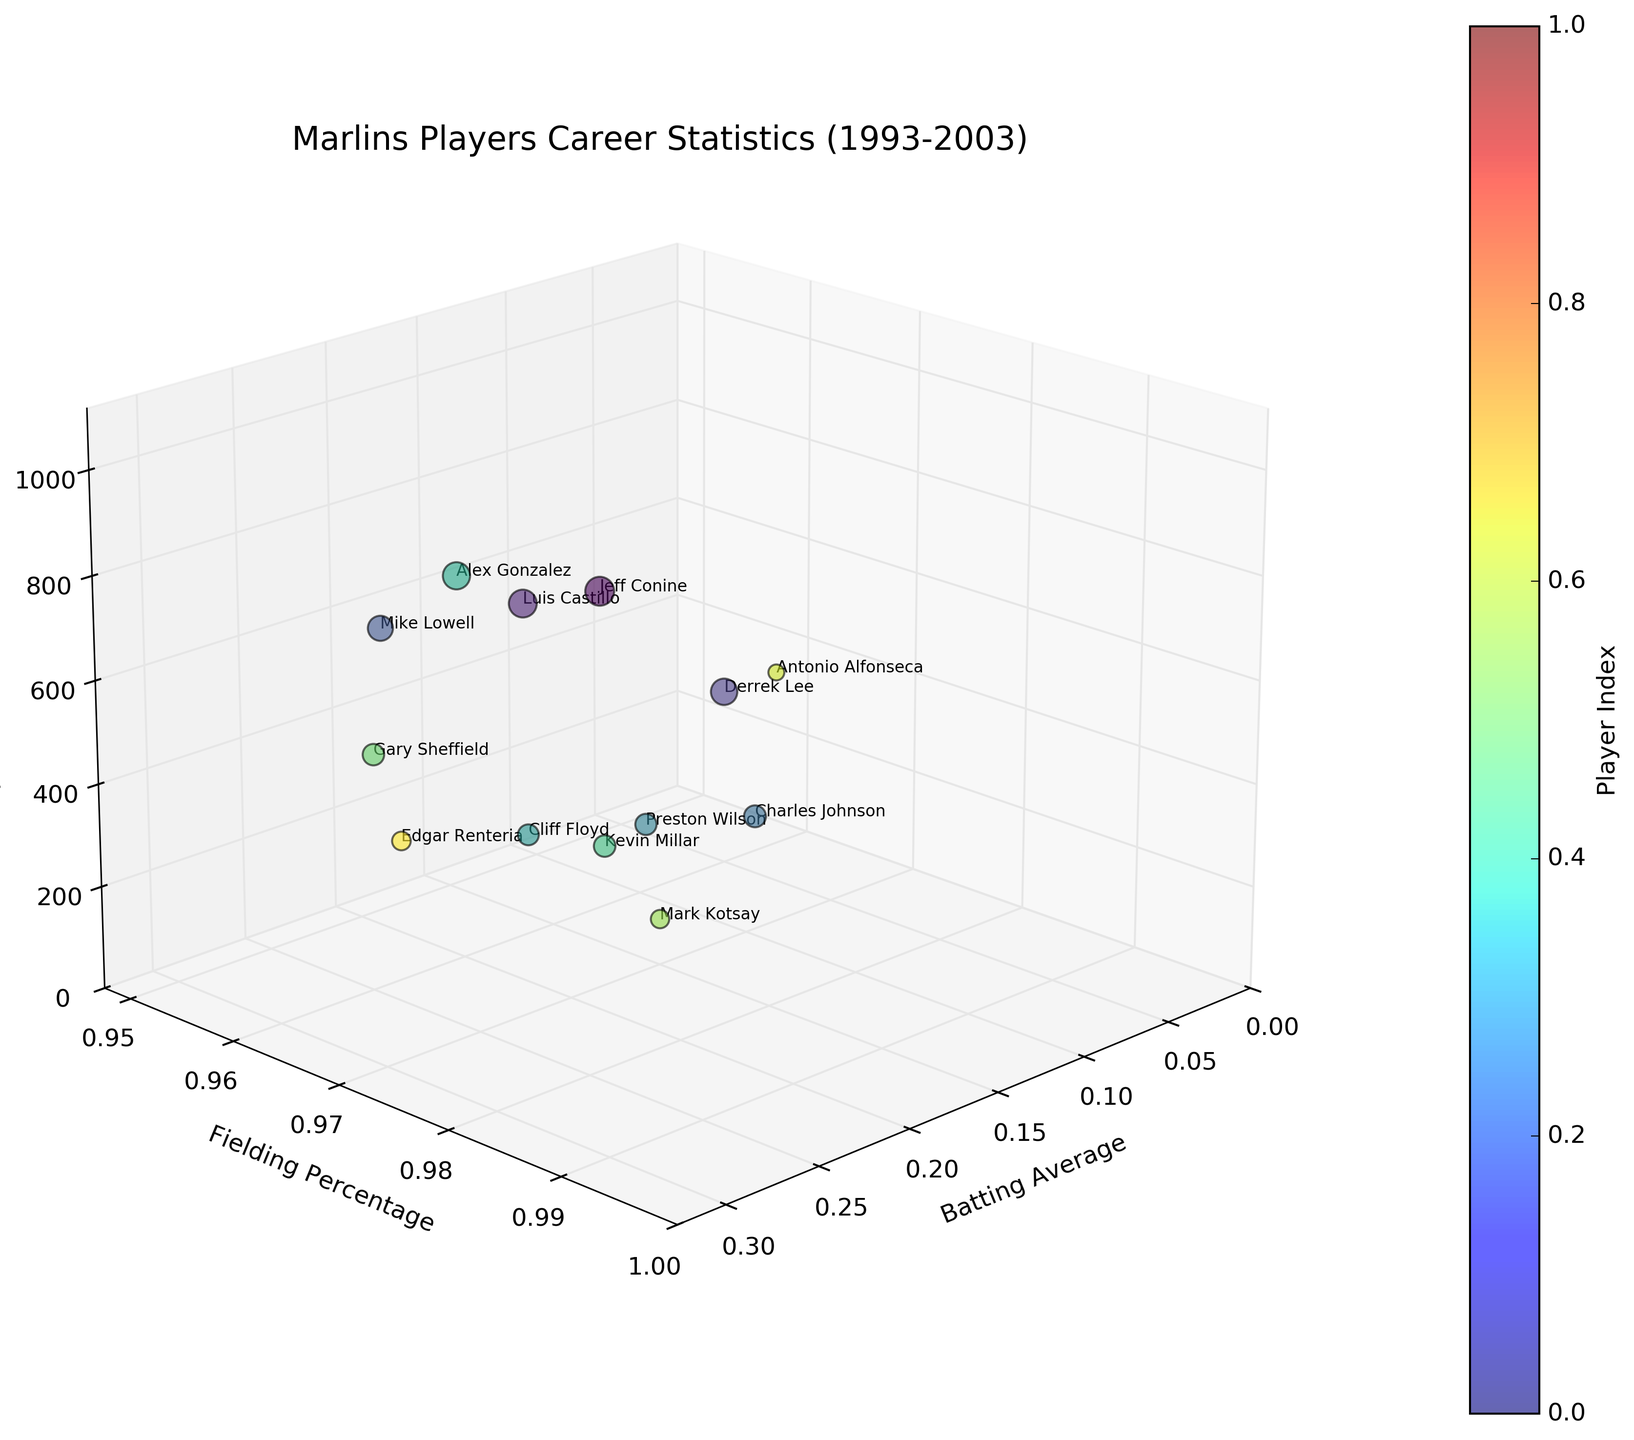What is the title of the chart? The title of the chart is usually written at the top of the figure. Here it is 'Marlins Players Career Statistics (1993-2003)'.
Answer: Marlins Players Career Statistics (1993-2003) Which player has the highest fielding percentage? By looking at the highest point on the y-axis (Fielding Percentage), the player with the highest fielding percentage is Derrek Lee with 0.994.
Answer: Derrek Lee Among Conine, Castillo, and Lee, who played the most games? By observing the z-axis (Games Played), Jeff Conine clearly has the highest value of 1014 games compared to Castillo's 941 and Lee's 844.
Answer: Jeff Conine What is the range of Batting Averages displayed on the x-axis? The x-axis (Batting Average) ranges from 0 to approximately the highest batting average shown. With the highest to be 0.296, the range is from 0 to 0.296.
Answer: 0 to 0.296 Which player has the highest Batting Average and how many games did they play? By looking at the highest point on the x-axis (Batting Average), Kevin Millar has the highest value of 0.296. He played 565 games, as indicated by his bubble size and position on the z-axis.
Answer: Kevin Millar, 565 Which player has the lowest fielding percentage and what is their Batting Average? The lowest fielding percentage on the y-axis is 0.957, belonging to Antonio Alfonseca, and his Batting Average is 0.000.
Answer: Antonio Alfonseca, 0.000 How does Cliff Floyd's batting average compare to Gary Sheffield's? Cliff Floyd's batting average is 0.294, whereas Gary Sheffield's is 0.288. Comparing the two, Floyd has a higher batting average.
Answer: Floyd's is higher Which player played fewer games, Charles Johnson or Mike Lowell? By looking at the z-axis (Games Played), Charles Johnson played 582 games, whereas Mike Lowell played 763 games. Thus, Johnson played fewer games.
Answer: Charles Johnson What is the relationship between Batting Average and Fielding Percentage for players with over 900 games played? By observing players with larger bubbles (>900 games), Jeff Conine has a batting average of 0.292 and fielding percentage of 0.988. Luis Castillo has a batting average of 0.290 and fielding percentage of 0.981. Both show high values for both metrics.
Answer: High Batting Average and Fielding Percentage Who has a better fielding percentage, Alex Gonzalez or Mark Kotsay, and how do their games played compare? Alex Gonzalez's fielding percentage is 0.971, and Mark Kotsay's is 0.990. Kotsay has a better fielding percentage. Alex Gonzalez played 896 games compared to Kotsay's 409.
Answer: Kotsay has a better fielding percentage, Gonzalez played more games 